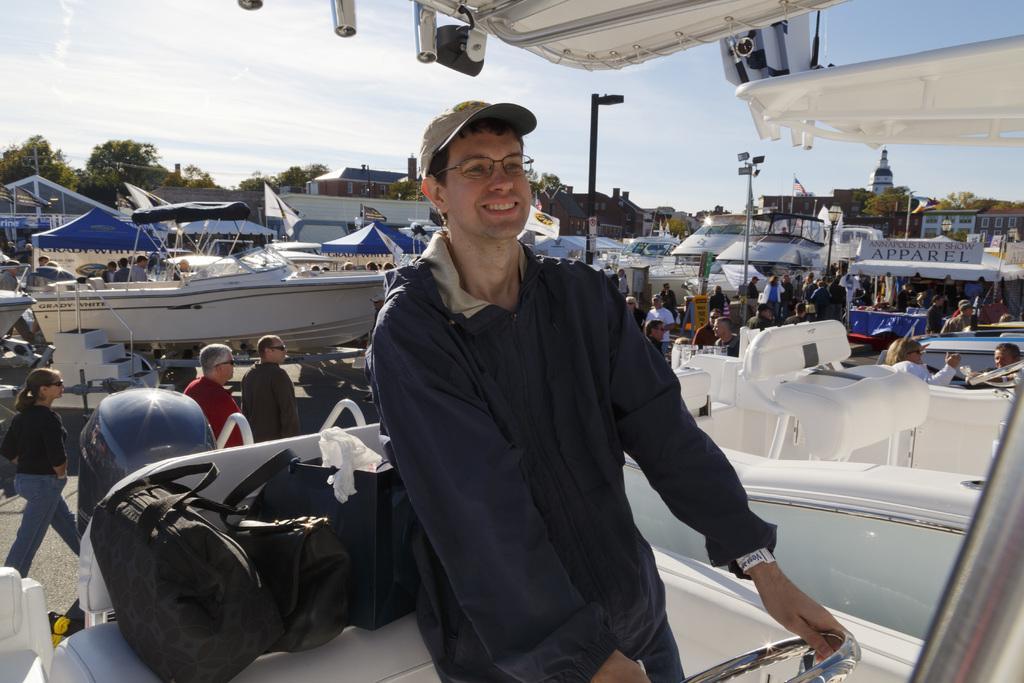How would you summarize this image in a sentence or two? In the background we can see the sky, trees. In this picture we can see the buildings, windows, tents, boats, tents, flags, poles, people, lights. We can see a man wearing a cap, spectacles and he is holding an object, it seems like a steering. He is smiling. We can see the bags. 